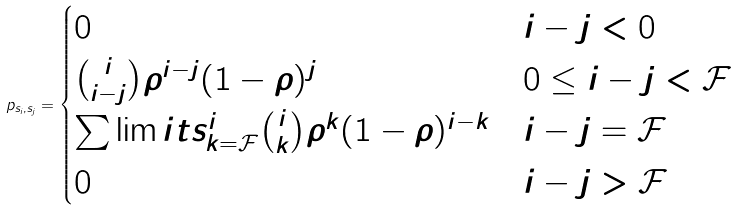Convert formula to latex. <formula><loc_0><loc_0><loc_500><loc_500>p _ { s _ { i } , s _ { j } } = \begin{cases} 0 & i - j < 0 \\ \binom { i } { i - j } \rho ^ { i - j } ( 1 - \rho ) ^ { j } & 0 \leq i - j < \mathcal { F } \\ \sum \lim i t s _ { k = \mathcal { F } } ^ { i } \binom { i } { k } \rho ^ { k } ( 1 - \rho ) ^ { i - k } & i - j = \mathcal { F } \\ 0 & i - j > \mathcal { F } \end{cases}</formula> 